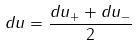Convert formula to latex. <formula><loc_0><loc_0><loc_500><loc_500>d u = \frac { d u _ { + } + d u _ { - } } { 2 }</formula> 